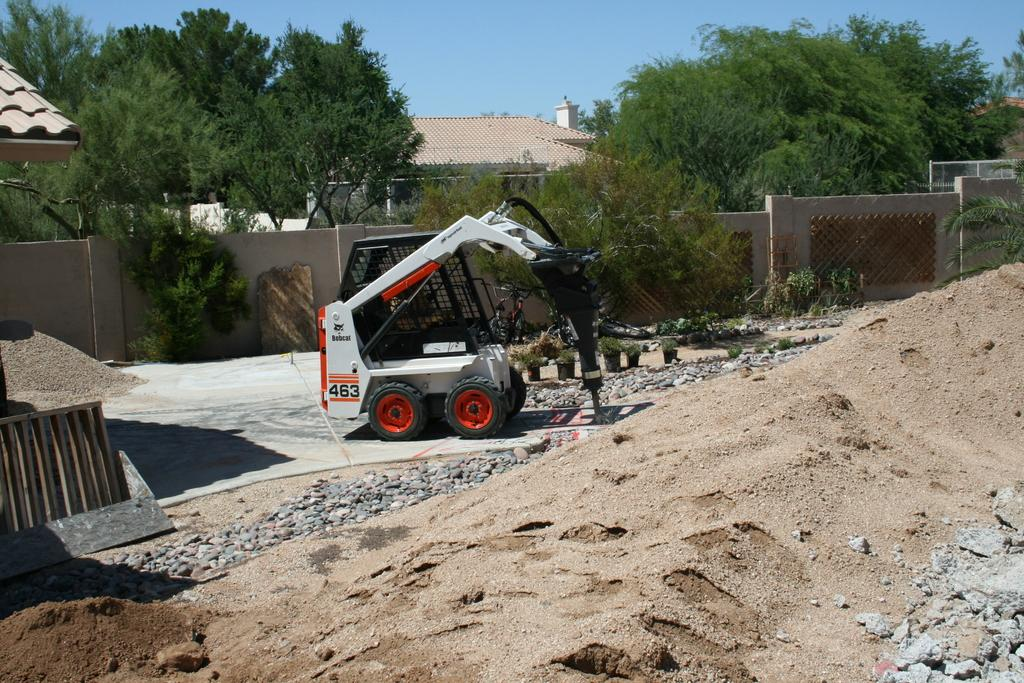What is the main subject of the image? There is a vehicle in the image. What other elements can be seen in the image besides the vehicle? There are plants, stones, sand, a wall, a house, trees, and the sky visible in the image. Can you describe the natural elements in the image? The image features plants, sand, and trees. What is the background of the image? The sky is visible in the background of the image. Where is the lace located in the image? There is no lace present in the image. What type of lunchroom can be seen in the image? There is no lunchroom present in the image. 